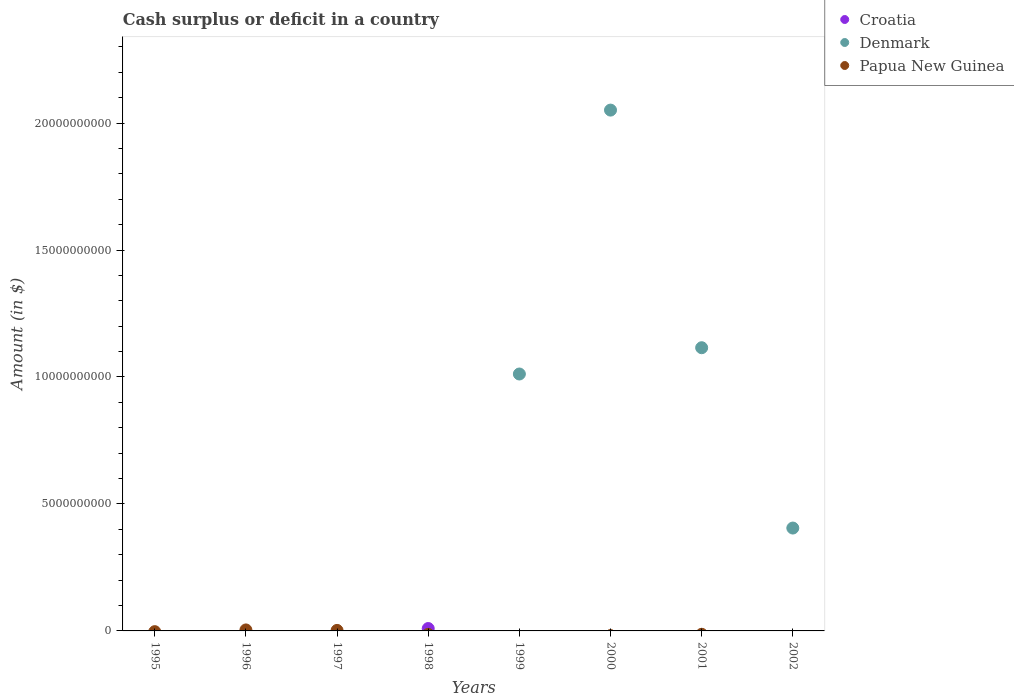What is the amount of cash surplus or deficit in Denmark in 1999?
Keep it short and to the point. 1.01e+1. Across all years, what is the maximum amount of cash surplus or deficit in Denmark?
Provide a succinct answer. 2.05e+1. Across all years, what is the minimum amount of cash surplus or deficit in Denmark?
Make the answer very short. 0. In which year was the amount of cash surplus or deficit in Denmark maximum?
Keep it short and to the point. 2000. What is the total amount of cash surplus or deficit in Papua New Guinea in the graph?
Ensure brevity in your answer.  5.92e+07. What is the difference between the amount of cash surplus or deficit in Papua New Guinea in 1996 and that in 1997?
Your answer should be compact. 1.85e+07. What is the difference between the amount of cash surplus or deficit in Papua New Guinea in 1998 and the amount of cash surplus or deficit in Croatia in 1999?
Offer a very short reply. 0. What is the average amount of cash surplus or deficit in Croatia per year?
Make the answer very short. 1.17e+07. In how many years, is the amount of cash surplus or deficit in Denmark greater than 19000000000 $?
Ensure brevity in your answer.  1. What is the difference between the highest and the lowest amount of cash surplus or deficit in Denmark?
Your response must be concise. 2.05e+1. In how many years, is the amount of cash surplus or deficit in Croatia greater than the average amount of cash surplus or deficit in Croatia taken over all years?
Provide a succinct answer. 1. Is it the case that in every year, the sum of the amount of cash surplus or deficit in Papua New Guinea and amount of cash surplus or deficit in Denmark  is greater than the amount of cash surplus or deficit in Croatia?
Ensure brevity in your answer.  No. Does the amount of cash surplus or deficit in Denmark monotonically increase over the years?
Offer a very short reply. No. Is the amount of cash surplus or deficit in Croatia strictly less than the amount of cash surplus or deficit in Denmark over the years?
Make the answer very short. No. How many dotlines are there?
Offer a very short reply. 3. How many years are there in the graph?
Your answer should be very brief. 8. Does the graph contain any zero values?
Your answer should be very brief. Yes. Does the graph contain grids?
Make the answer very short. No. Where does the legend appear in the graph?
Provide a succinct answer. Top right. How many legend labels are there?
Make the answer very short. 3. How are the legend labels stacked?
Make the answer very short. Vertical. What is the title of the graph?
Provide a succinct answer. Cash surplus or deficit in a country. Does "Greece" appear as one of the legend labels in the graph?
Offer a very short reply. No. What is the label or title of the X-axis?
Keep it short and to the point. Years. What is the label or title of the Y-axis?
Your answer should be very brief. Amount (in $). What is the Amount (in $) of Croatia in 1996?
Ensure brevity in your answer.  0. What is the Amount (in $) of Papua New Guinea in 1996?
Your answer should be very brief. 3.88e+07. What is the Amount (in $) in Denmark in 1997?
Keep it short and to the point. 0. What is the Amount (in $) in Papua New Guinea in 1997?
Provide a succinct answer. 2.03e+07. What is the Amount (in $) in Croatia in 1998?
Your answer should be compact. 9.39e+07. What is the Amount (in $) of Croatia in 1999?
Make the answer very short. 0. What is the Amount (in $) in Denmark in 1999?
Your answer should be compact. 1.01e+1. What is the Amount (in $) of Denmark in 2000?
Provide a short and direct response. 2.05e+1. What is the Amount (in $) in Papua New Guinea in 2000?
Provide a succinct answer. 0. What is the Amount (in $) of Denmark in 2001?
Make the answer very short. 1.12e+1. What is the Amount (in $) of Papua New Guinea in 2001?
Offer a very short reply. 0. What is the Amount (in $) in Denmark in 2002?
Give a very brief answer. 4.05e+09. Across all years, what is the maximum Amount (in $) of Croatia?
Provide a short and direct response. 9.39e+07. Across all years, what is the maximum Amount (in $) of Denmark?
Provide a short and direct response. 2.05e+1. Across all years, what is the maximum Amount (in $) of Papua New Guinea?
Keep it short and to the point. 3.88e+07. Across all years, what is the minimum Amount (in $) of Croatia?
Your answer should be very brief. 0. Across all years, what is the minimum Amount (in $) of Denmark?
Ensure brevity in your answer.  0. Across all years, what is the minimum Amount (in $) in Papua New Guinea?
Offer a very short reply. 0. What is the total Amount (in $) in Croatia in the graph?
Provide a short and direct response. 9.39e+07. What is the total Amount (in $) of Denmark in the graph?
Offer a very short reply. 4.58e+1. What is the total Amount (in $) of Papua New Guinea in the graph?
Your answer should be very brief. 5.92e+07. What is the difference between the Amount (in $) of Papua New Guinea in 1996 and that in 1997?
Provide a short and direct response. 1.85e+07. What is the difference between the Amount (in $) of Denmark in 1999 and that in 2000?
Keep it short and to the point. -1.04e+1. What is the difference between the Amount (in $) of Denmark in 1999 and that in 2001?
Offer a very short reply. -1.04e+09. What is the difference between the Amount (in $) in Denmark in 1999 and that in 2002?
Provide a succinct answer. 6.07e+09. What is the difference between the Amount (in $) of Denmark in 2000 and that in 2001?
Give a very brief answer. 9.36e+09. What is the difference between the Amount (in $) in Denmark in 2000 and that in 2002?
Keep it short and to the point. 1.65e+1. What is the difference between the Amount (in $) in Denmark in 2001 and that in 2002?
Your answer should be compact. 7.10e+09. What is the difference between the Amount (in $) of Croatia in 1998 and the Amount (in $) of Denmark in 1999?
Give a very brief answer. -1.00e+1. What is the difference between the Amount (in $) in Croatia in 1998 and the Amount (in $) in Denmark in 2000?
Provide a short and direct response. -2.04e+1. What is the difference between the Amount (in $) in Croatia in 1998 and the Amount (in $) in Denmark in 2001?
Ensure brevity in your answer.  -1.11e+1. What is the difference between the Amount (in $) of Croatia in 1998 and the Amount (in $) of Denmark in 2002?
Offer a very short reply. -3.96e+09. What is the average Amount (in $) in Croatia per year?
Provide a succinct answer. 1.17e+07. What is the average Amount (in $) in Denmark per year?
Give a very brief answer. 5.73e+09. What is the average Amount (in $) in Papua New Guinea per year?
Provide a short and direct response. 7.39e+06. What is the ratio of the Amount (in $) in Papua New Guinea in 1996 to that in 1997?
Provide a short and direct response. 1.91. What is the ratio of the Amount (in $) in Denmark in 1999 to that in 2000?
Make the answer very short. 0.49. What is the ratio of the Amount (in $) in Denmark in 1999 to that in 2001?
Offer a terse response. 0.91. What is the ratio of the Amount (in $) in Denmark in 1999 to that in 2002?
Offer a very short reply. 2.5. What is the ratio of the Amount (in $) of Denmark in 2000 to that in 2001?
Your answer should be compact. 1.84. What is the ratio of the Amount (in $) in Denmark in 2000 to that in 2002?
Provide a short and direct response. 5.06. What is the ratio of the Amount (in $) of Denmark in 2001 to that in 2002?
Ensure brevity in your answer.  2.75. What is the difference between the highest and the second highest Amount (in $) of Denmark?
Your answer should be compact. 9.36e+09. What is the difference between the highest and the lowest Amount (in $) in Croatia?
Provide a short and direct response. 9.39e+07. What is the difference between the highest and the lowest Amount (in $) of Denmark?
Provide a short and direct response. 2.05e+1. What is the difference between the highest and the lowest Amount (in $) in Papua New Guinea?
Make the answer very short. 3.88e+07. 